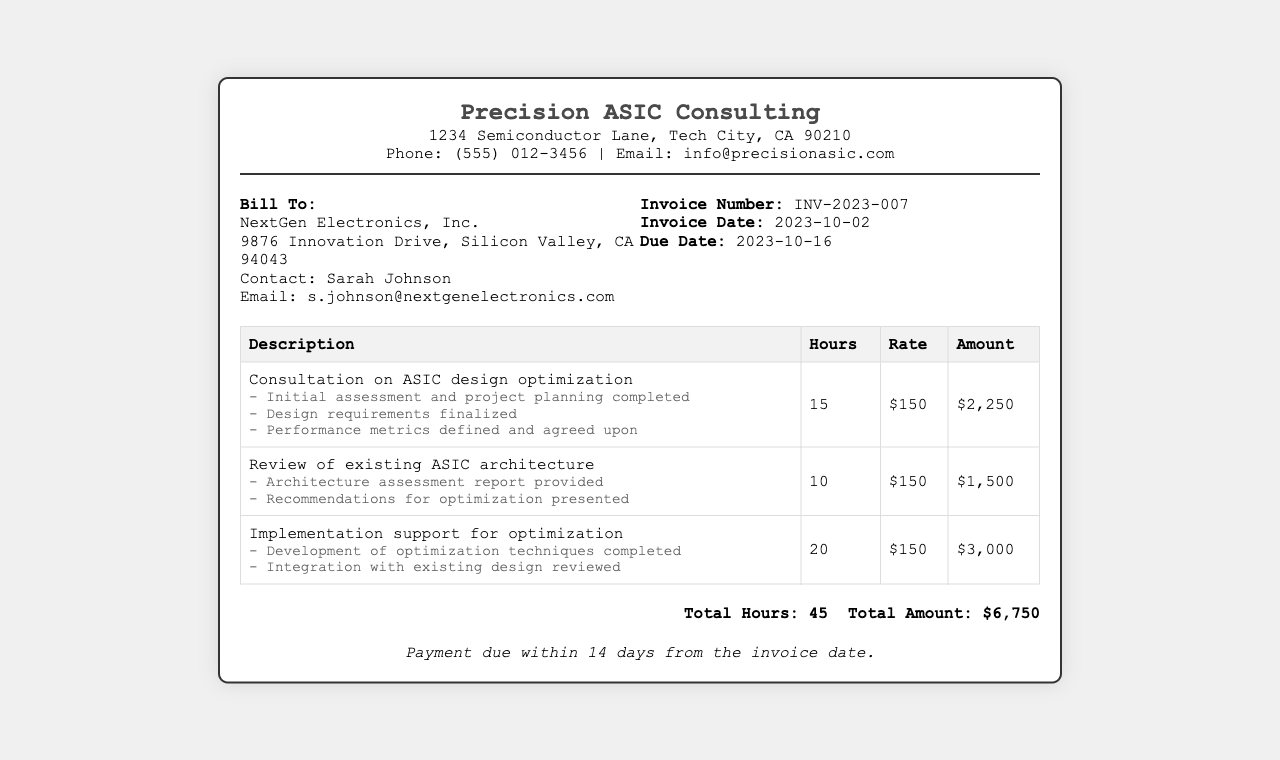What is the invoice number? The invoice number is stated in the invoice info section, which is INV-2023-007.
Answer: INV-2023-007 Who is the contact person for the client? The contact person for NextGen Electronics, Inc. is mentioned in the client details section as Sarah Johnson.
Answer: Sarah Johnson What is the due date for the invoice? The due date is provided in the invoice info section as 2023-10-16.
Answer: 2023-10-16 How many total hours were worked on the project? The total hours are summarized at the bottom of the document, which states 45 total hours worked.
Answer: 45 What is the hourly rate for the services provided? The hourly rate is consistently listed in the invoice as $150.
Answer: $150 What was involved in the review of existing ASIC architecture? The milestones for this service include "Architecture assessment report provided" and "Recommendations for optimization presented."
Answer: Architecture assessment report provided What is the total amount due for services? The total amount is summarized in the document as $6,750.
Answer: $6,750 What is the primary service provided in the consultation? The primary service mentioned is "Consultation on ASIC design optimization."
Answer: Consultation on ASIC design optimization How many hours were spent on implementation support for optimization? The document specifies that 20 hours were allocated for implementation support for optimization.
Answer: 20 